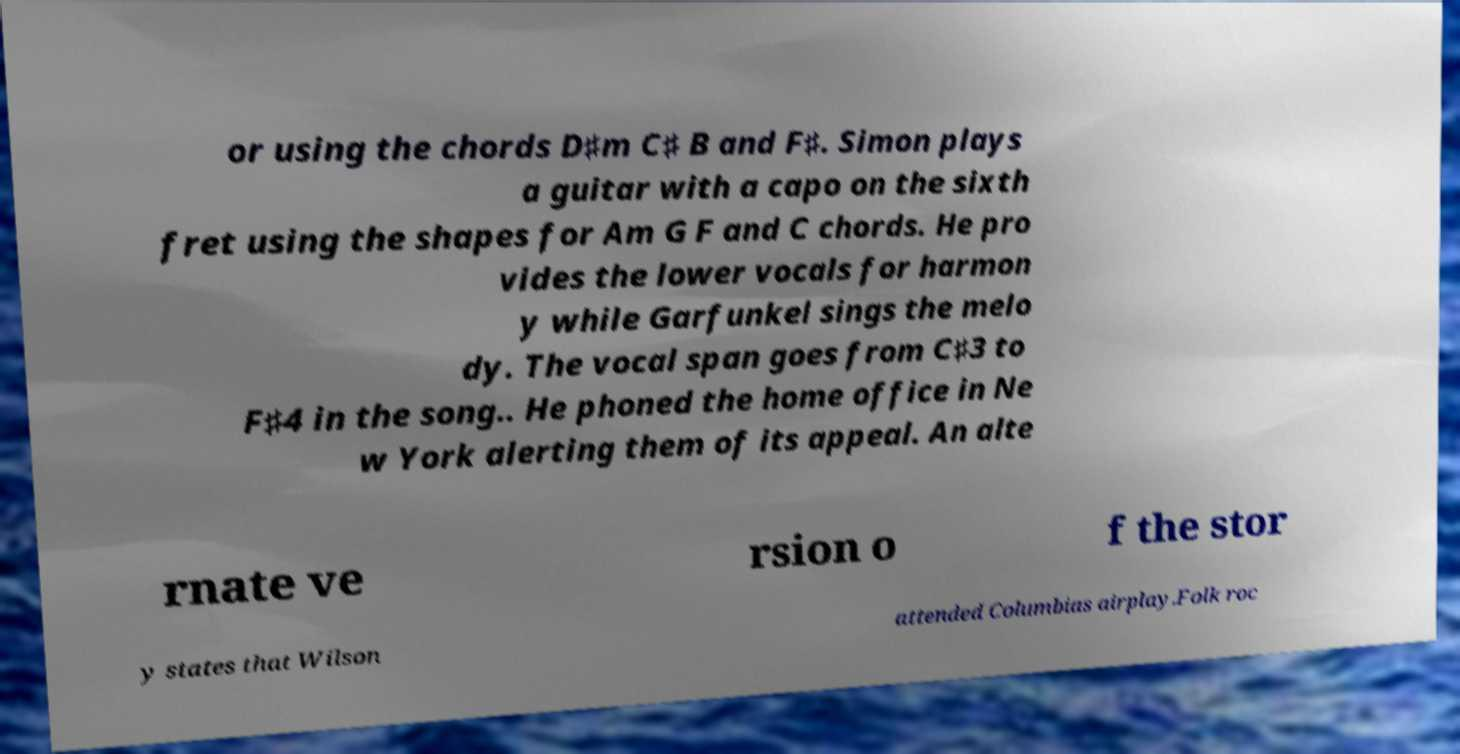Could you assist in decoding the text presented in this image and type it out clearly? or using the chords D♯m C♯ B and F♯. Simon plays a guitar with a capo on the sixth fret using the shapes for Am G F and C chords. He pro vides the lower vocals for harmon y while Garfunkel sings the melo dy. The vocal span goes from C♯3 to F♯4 in the song.. He phoned the home office in Ne w York alerting them of its appeal. An alte rnate ve rsion o f the stor y states that Wilson attended Columbias airplay.Folk roc 